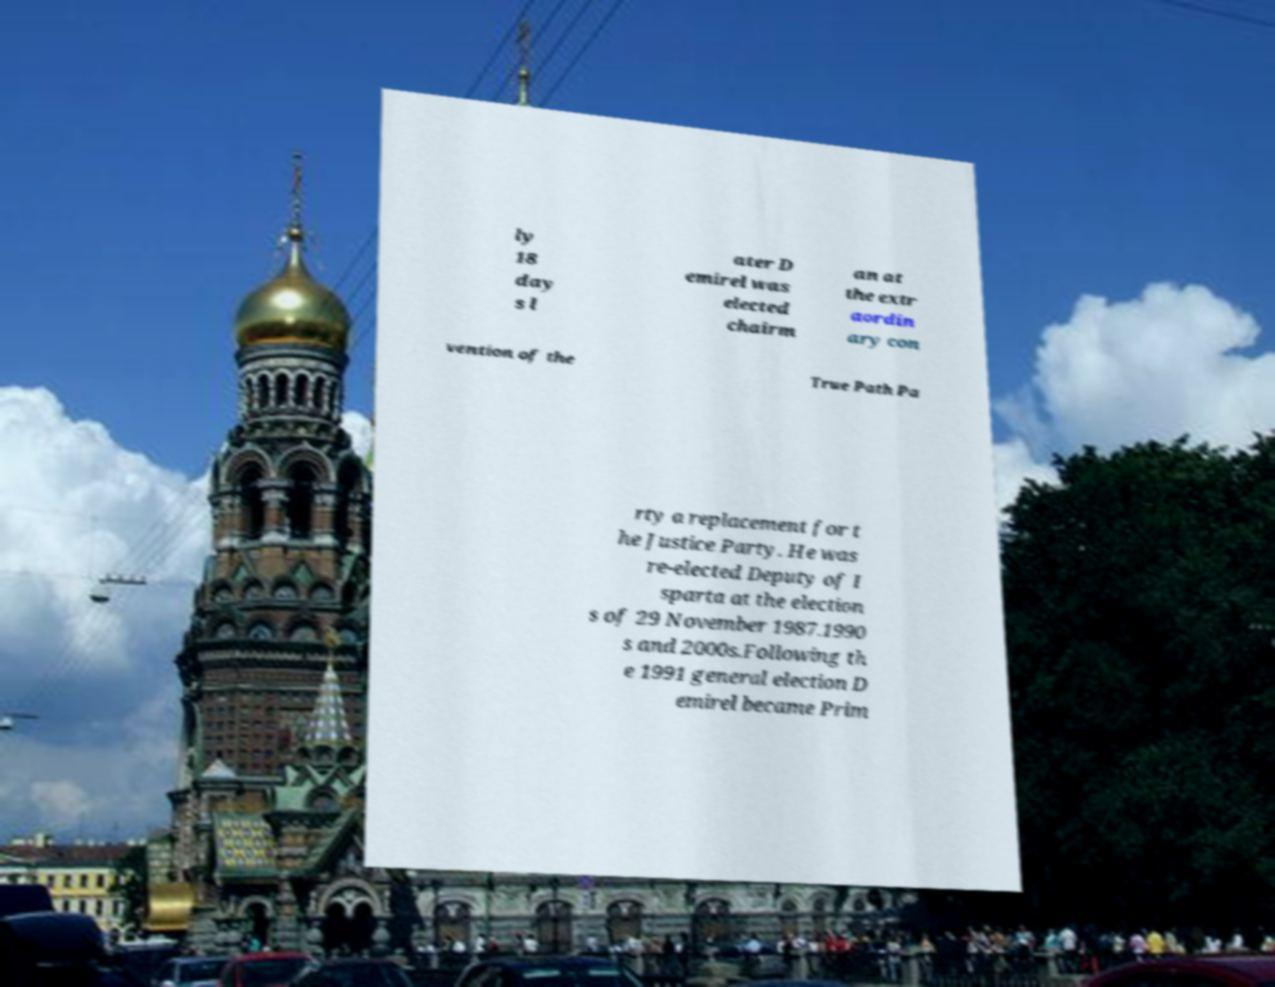Can you read and provide the text displayed in the image?This photo seems to have some interesting text. Can you extract and type it out for me? ly 18 day s l ater D emirel was elected chairm an at the extr aordin ary con vention of the True Path Pa rty a replacement for t he Justice Party. He was re-elected Deputy of I sparta at the election s of 29 November 1987.1990 s and 2000s.Following th e 1991 general election D emirel became Prim 